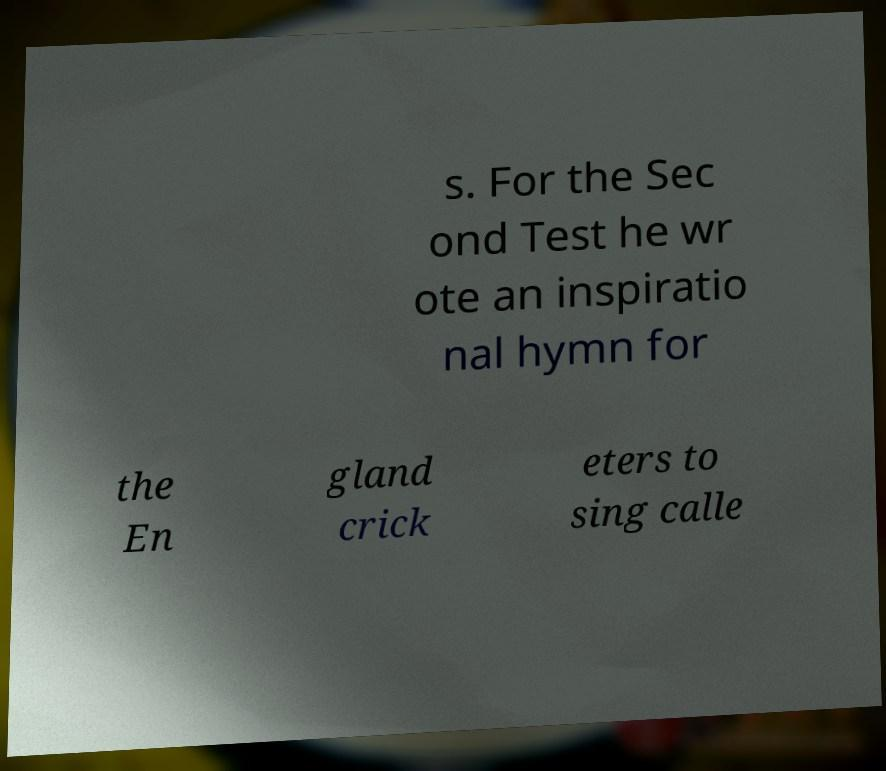Could you extract and type out the text from this image? s. For the Sec ond Test he wr ote an inspiratio nal hymn for the En gland crick eters to sing calle 